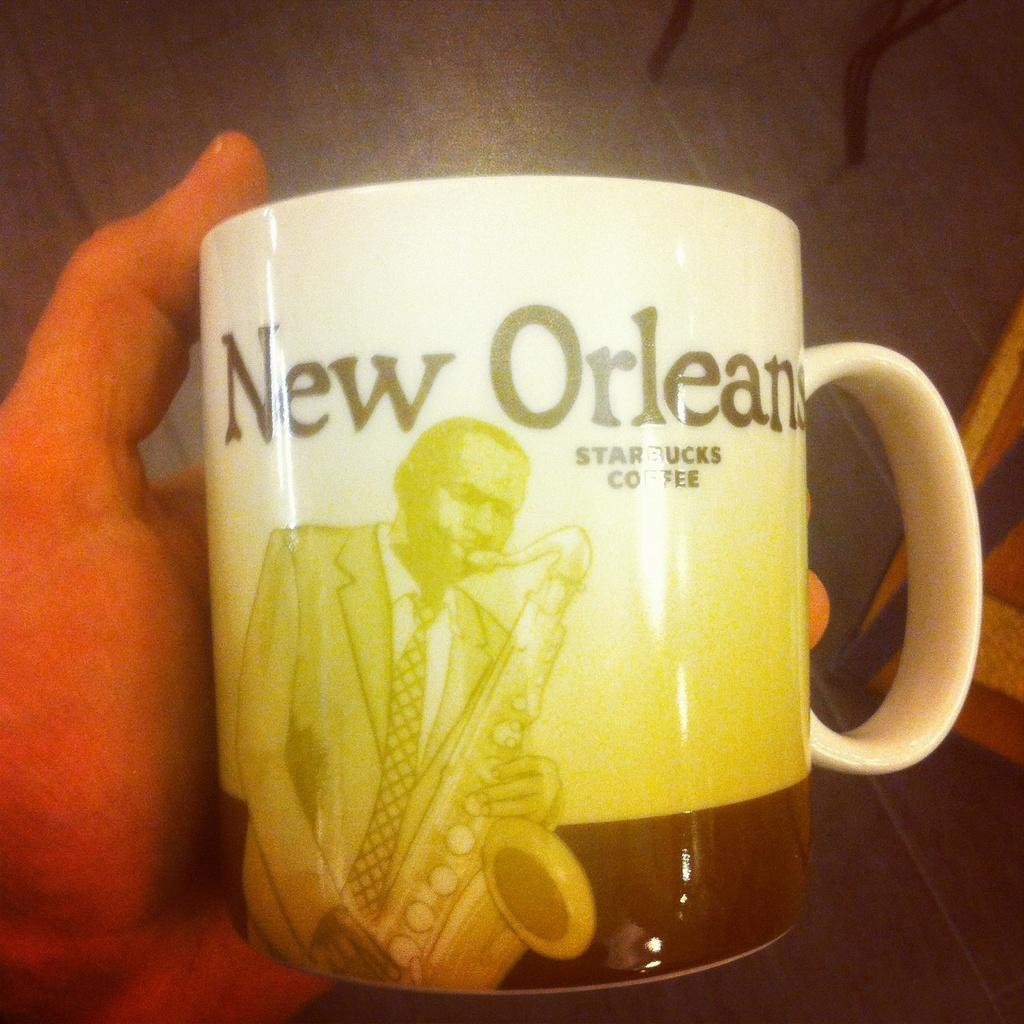<image>
Describe the image concisely. A Starbucks cup featuring a sax player that says New Orleans on it. 